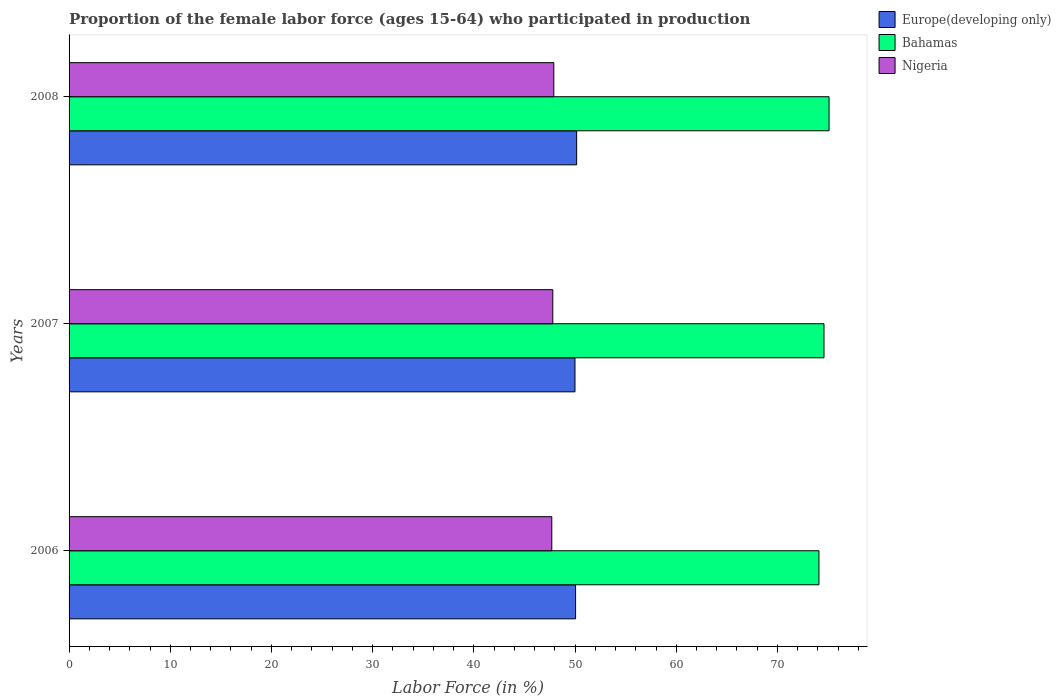How many different coloured bars are there?
Give a very brief answer. 3. Are the number of bars per tick equal to the number of legend labels?
Your answer should be compact. Yes. Are the number of bars on each tick of the Y-axis equal?
Offer a terse response. Yes. In how many cases, is the number of bars for a given year not equal to the number of legend labels?
Provide a short and direct response. 0. What is the proportion of the female labor force who participated in production in Nigeria in 2008?
Give a very brief answer. 47.9. Across all years, what is the maximum proportion of the female labor force who participated in production in Europe(developing only)?
Your answer should be compact. 50.16. Across all years, what is the minimum proportion of the female labor force who participated in production in Nigeria?
Offer a very short reply. 47.7. In which year was the proportion of the female labor force who participated in production in Bahamas maximum?
Your response must be concise. 2008. What is the total proportion of the female labor force who participated in production in Nigeria in the graph?
Provide a succinct answer. 143.4. What is the difference between the proportion of the female labor force who participated in production in Europe(developing only) in 2006 and that in 2007?
Provide a short and direct response. 0.06. What is the difference between the proportion of the female labor force who participated in production in Nigeria in 2008 and the proportion of the female labor force who participated in production in Bahamas in 2007?
Give a very brief answer. -26.7. What is the average proportion of the female labor force who participated in production in Europe(developing only) per year?
Keep it short and to the point. 50.07. In the year 2007, what is the difference between the proportion of the female labor force who participated in production in Nigeria and proportion of the female labor force who participated in production in Bahamas?
Keep it short and to the point. -26.8. What is the ratio of the proportion of the female labor force who participated in production in Europe(developing only) in 2007 to that in 2008?
Provide a short and direct response. 1. What is the difference between the highest and the second highest proportion of the female labor force who participated in production in Europe(developing only)?
Offer a very short reply. 0.11. What is the difference between the highest and the lowest proportion of the female labor force who participated in production in Europe(developing only)?
Make the answer very short. 0.16. In how many years, is the proportion of the female labor force who participated in production in Nigeria greater than the average proportion of the female labor force who participated in production in Nigeria taken over all years?
Give a very brief answer. 1. Is the sum of the proportion of the female labor force who participated in production in Bahamas in 2006 and 2007 greater than the maximum proportion of the female labor force who participated in production in Nigeria across all years?
Ensure brevity in your answer.  Yes. What does the 1st bar from the top in 2008 represents?
Give a very brief answer. Nigeria. What does the 2nd bar from the bottom in 2007 represents?
Make the answer very short. Bahamas. How many bars are there?
Your answer should be compact. 9. Are all the bars in the graph horizontal?
Your response must be concise. Yes. Are the values on the major ticks of X-axis written in scientific E-notation?
Make the answer very short. No. Does the graph contain grids?
Your response must be concise. No. Where does the legend appear in the graph?
Give a very brief answer. Top right. What is the title of the graph?
Offer a terse response. Proportion of the female labor force (ages 15-64) who participated in production. What is the label or title of the Y-axis?
Provide a succinct answer. Years. What is the Labor Force (in %) in Europe(developing only) in 2006?
Make the answer very short. 50.05. What is the Labor Force (in %) in Bahamas in 2006?
Make the answer very short. 74.1. What is the Labor Force (in %) in Nigeria in 2006?
Keep it short and to the point. 47.7. What is the Labor Force (in %) in Europe(developing only) in 2007?
Ensure brevity in your answer.  49.99. What is the Labor Force (in %) of Bahamas in 2007?
Give a very brief answer. 74.6. What is the Labor Force (in %) of Nigeria in 2007?
Provide a succinct answer. 47.8. What is the Labor Force (in %) in Europe(developing only) in 2008?
Provide a short and direct response. 50.16. What is the Labor Force (in %) of Bahamas in 2008?
Provide a short and direct response. 75.1. What is the Labor Force (in %) of Nigeria in 2008?
Ensure brevity in your answer.  47.9. Across all years, what is the maximum Labor Force (in %) in Europe(developing only)?
Give a very brief answer. 50.16. Across all years, what is the maximum Labor Force (in %) of Bahamas?
Ensure brevity in your answer.  75.1. Across all years, what is the maximum Labor Force (in %) in Nigeria?
Provide a short and direct response. 47.9. Across all years, what is the minimum Labor Force (in %) in Europe(developing only)?
Make the answer very short. 49.99. Across all years, what is the minimum Labor Force (in %) in Bahamas?
Make the answer very short. 74.1. Across all years, what is the minimum Labor Force (in %) of Nigeria?
Provide a short and direct response. 47.7. What is the total Labor Force (in %) of Europe(developing only) in the graph?
Keep it short and to the point. 150.2. What is the total Labor Force (in %) in Bahamas in the graph?
Your response must be concise. 223.8. What is the total Labor Force (in %) of Nigeria in the graph?
Make the answer very short. 143.4. What is the difference between the Labor Force (in %) of Europe(developing only) in 2006 and that in 2007?
Keep it short and to the point. 0.06. What is the difference between the Labor Force (in %) in Bahamas in 2006 and that in 2007?
Offer a terse response. -0.5. What is the difference between the Labor Force (in %) in Nigeria in 2006 and that in 2007?
Provide a short and direct response. -0.1. What is the difference between the Labor Force (in %) in Europe(developing only) in 2006 and that in 2008?
Your response must be concise. -0.11. What is the difference between the Labor Force (in %) of Nigeria in 2006 and that in 2008?
Your response must be concise. -0.2. What is the difference between the Labor Force (in %) of Europe(developing only) in 2007 and that in 2008?
Your answer should be compact. -0.16. What is the difference between the Labor Force (in %) in Nigeria in 2007 and that in 2008?
Your answer should be very brief. -0.1. What is the difference between the Labor Force (in %) of Europe(developing only) in 2006 and the Labor Force (in %) of Bahamas in 2007?
Provide a short and direct response. -24.55. What is the difference between the Labor Force (in %) of Europe(developing only) in 2006 and the Labor Force (in %) of Nigeria in 2007?
Provide a succinct answer. 2.25. What is the difference between the Labor Force (in %) of Bahamas in 2006 and the Labor Force (in %) of Nigeria in 2007?
Provide a short and direct response. 26.3. What is the difference between the Labor Force (in %) of Europe(developing only) in 2006 and the Labor Force (in %) of Bahamas in 2008?
Provide a short and direct response. -25.05. What is the difference between the Labor Force (in %) of Europe(developing only) in 2006 and the Labor Force (in %) of Nigeria in 2008?
Ensure brevity in your answer.  2.15. What is the difference between the Labor Force (in %) of Bahamas in 2006 and the Labor Force (in %) of Nigeria in 2008?
Give a very brief answer. 26.2. What is the difference between the Labor Force (in %) of Europe(developing only) in 2007 and the Labor Force (in %) of Bahamas in 2008?
Offer a very short reply. -25.11. What is the difference between the Labor Force (in %) of Europe(developing only) in 2007 and the Labor Force (in %) of Nigeria in 2008?
Your response must be concise. 2.09. What is the difference between the Labor Force (in %) of Bahamas in 2007 and the Labor Force (in %) of Nigeria in 2008?
Provide a succinct answer. 26.7. What is the average Labor Force (in %) in Europe(developing only) per year?
Your response must be concise. 50.07. What is the average Labor Force (in %) in Bahamas per year?
Your answer should be very brief. 74.6. What is the average Labor Force (in %) of Nigeria per year?
Keep it short and to the point. 47.8. In the year 2006, what is the difference between the Labor Force (in %) of Europe(developing only) and Labor Force (in %) of Bahamas?
Offer a terse response. -24.05. In the year 2006, what is the difference between the Labor Force (in %) of Europe(developing only) and Labor Force (in %) of Nigeria?
Offer a very short reply. 2.35. In the year 2006, what is the difference between the Labor Force (in %) of Bahamas and Labor Force (in %) of Nigeria?
Ensure brevity in your answer.  26.4. In the year 2007, what is the difference between the Labor Force (in %) of Europe(developing only) and Labor Force (in %) of Bahamas?
Provide a short and direct response. -24.61. In the year 2007, what is the difference between the Labor Force (in %) in Europe(developing only) and Labor Force (in %) in Nigeria?
Your answer should be very brief. 2.19. In the year 2007, what is the difference between the Labor Force (in %) of Bahamas and Labor Force (in %) of Nigeria?
Provide a short and direct response. 26.8. In the year 2008, what is the difference between the Labor Force (in %) in Europe(developing only) and Labor Force (in %) in Bahamas?
Provide a succinct answer. -24.94. In the year 2008, what is the difference between the Labor Force (in %) of Europe(developing only) and Labor Force (in %) of Nigeria?
Keep it short and to the point. 2.26. In the year 2008, what is the difference between the Labor Force (in %) of Bahamas and Labor Force (in %) of Nigeria?
Provide a short and direct response. 27.2. What is the ratio of the Labor Force (in %) of Europe(developing only) in 2006 to that in 2007?
Give a very brief answer. 1. What is the ratio of the Labor Force (in %) of Nigeria in 2006 to that in 2007?
Provide a short and direct response. 1. What is the ratio of the Labor Force (in %) in Europe(developing only) in 2006 to that in 2008?
Provide a short and direct response. 1. What is the ratio of the Labor Force (in %) in Bahamas in 2006 to that in 2008?
Your answer should be very brief. 0.99. What is the ratio of the Labor Force (in %) in Nigeria in 2006 to that in 2008?
Provide a short and direct response. 1. What is the ratio of the Labor Force (in %) of Bahamas in 2007 to that in 2008?
Keep it short and to the point. 0.99. What is the difference between the highest and the second highest Labor Force (in %) in Europe(developing only)?
Your answer should be compact. 0.11. What is the difference between the highest and the second highest Labor Force (in %) of Bahamas?
Offer a terse response. 0.5. What is the difference between the highest and the second highest Labor Force (in %) of Nigeria?
Your answer should be very brief. 0.1. What is the difference between the highest and the lowest Labor Force (in %) in Europe(developing only)?
Your answer should be very brief. 0.16. 